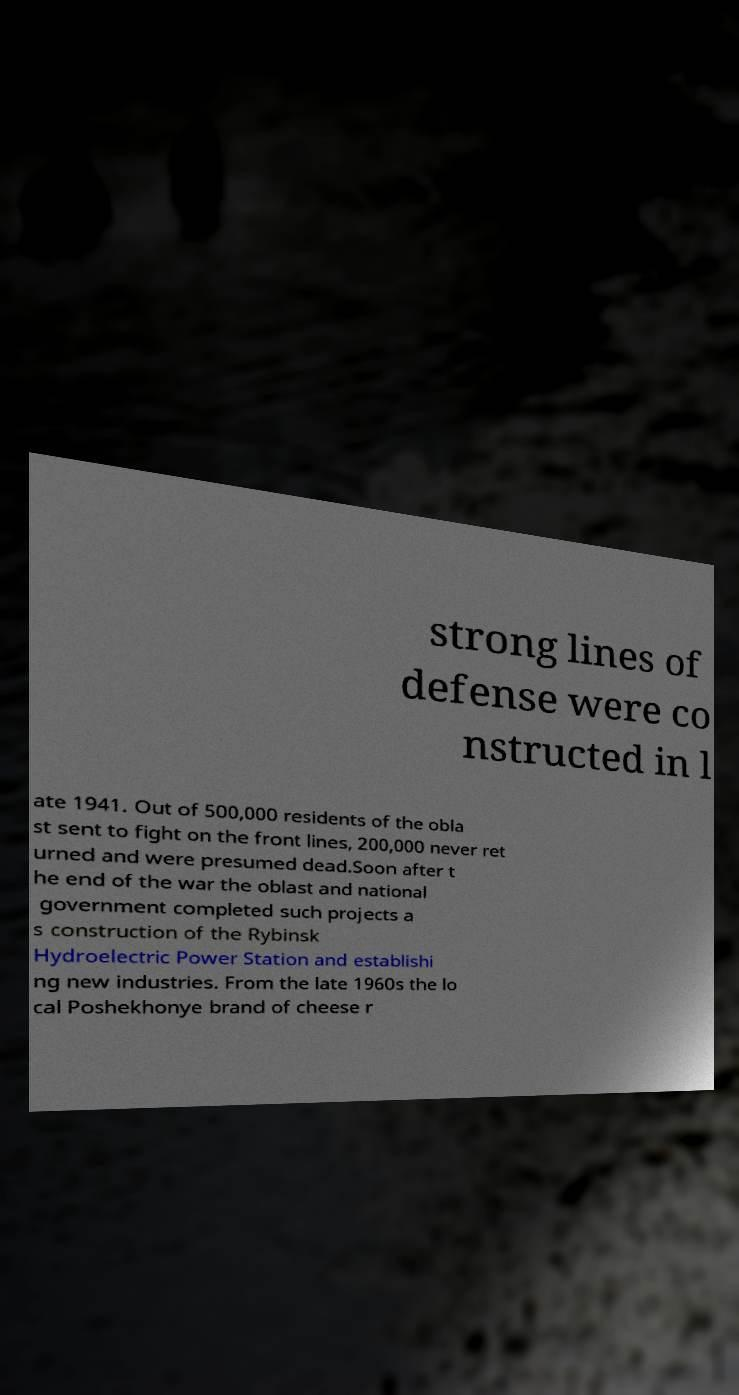Can you read and provide the text displayed in the image?This photo seems to have some interesting text. Can you extract and type it out for me? strong lines of defense were co nstructed in l ate 1941. Out of 500,000 residents of the obla st sent to fight on the front lines, 200,000 never ret urned and were presumed dead.Soon after t he end of the war the oblast and national government completed such projects a s construction of the Rybinsk Hydroelectric Power Station and establishi ng new industries. From the late 1960s the lo cal Poshekhonye brand of cheese r 